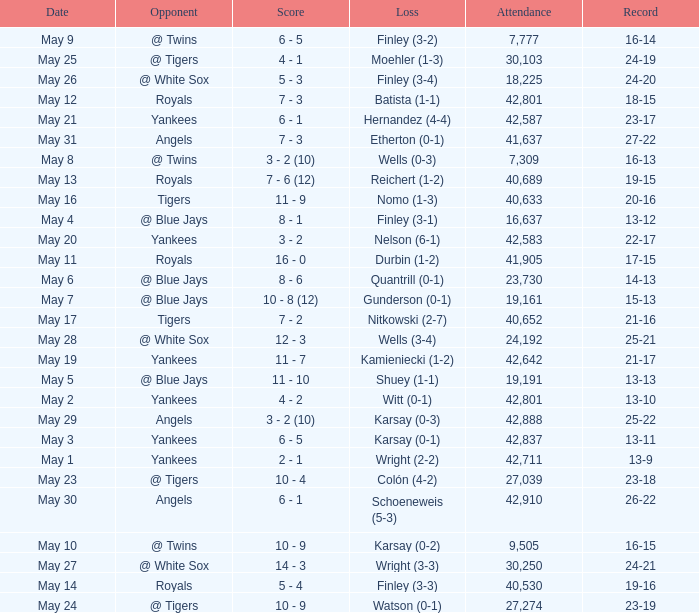What is the attendance for the game on May 25? 30103.0. 